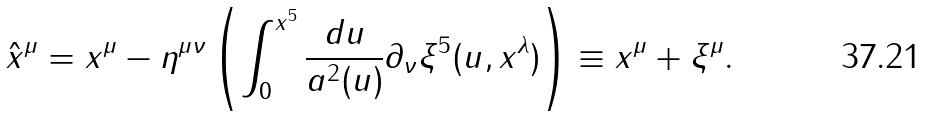<formula> <loc_0><loc_0><loc_500><loc_500>\hat { x } ^ { \mu } = x ^ { \mu } - \eta ^ { \mu \nu } \left ( \int _ { 0 } ^ { x ^ { 5 } } \frac { d u } { a ^ { 2 } ( u ) } \partial _ { \nu } \xi ^ { 5 } ( u , x ^ { \lambda } ) \right ) \equiv x ^ { \mu } + \xi ^ { \mu } .</formula> 